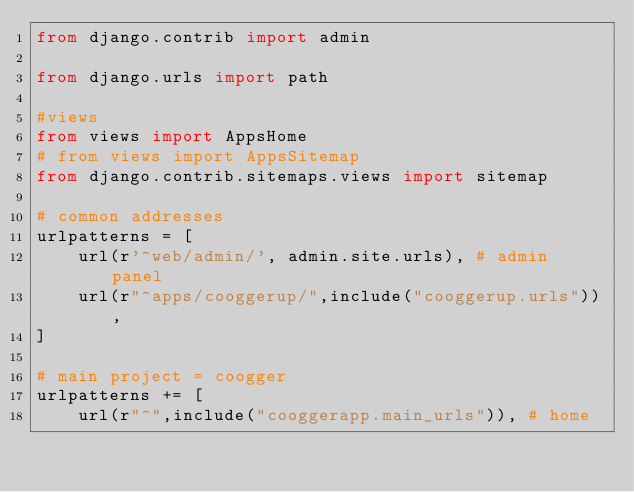<code> <loc_0><loc_0><loc_500><loc_500><_Python_>from django.contrib import admin

from django.urls import path

#views
from views import AppsHome
# from views import AppsSitemap
from django.contrib.sitemaps.views import sitemap

# common addresses
urlpatterns = [
    url(r'^web/admin/', admin.site.urls), # admin panel
    url(r"^apps/cooggerup/",include("cooggerup.urls")),
]

# main project = coogger
urlpatterns += [
    url(r"^",include("cooggerapp.main_urls")), # home</code> 